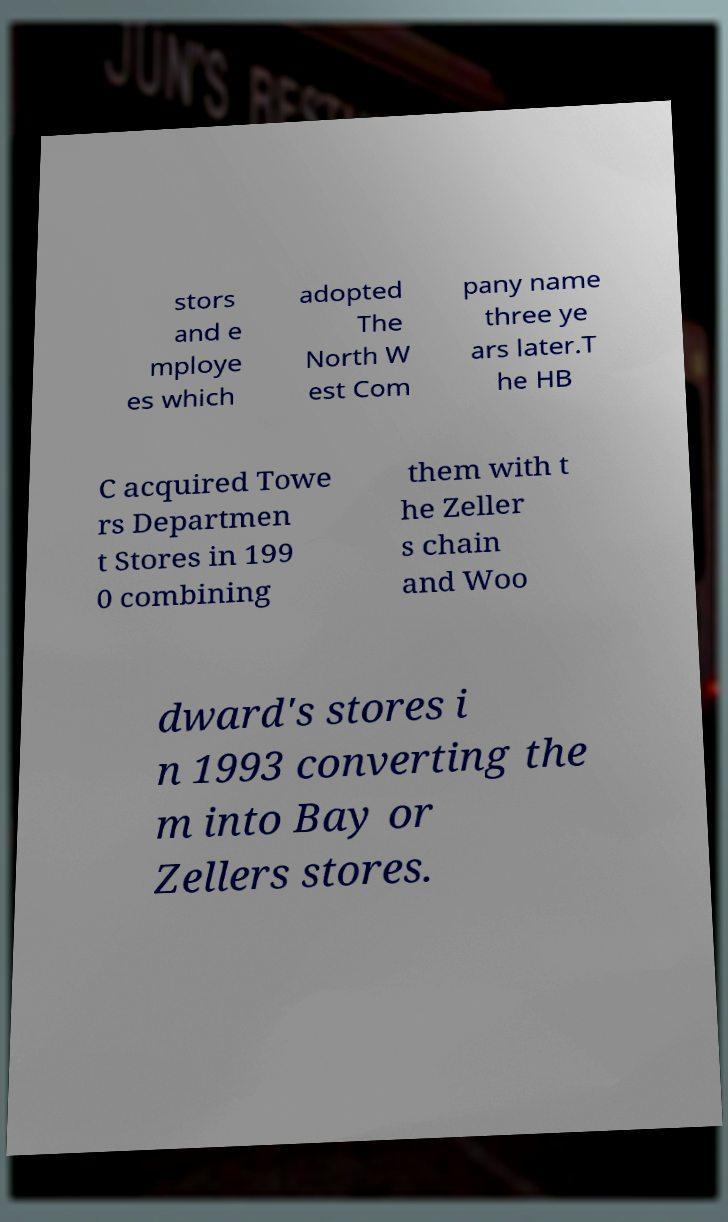Can you accurately transcribe the text from the provided image for me? stors and e mploye es which adopted The North W est Com pany name three ye ars later.T he HB C acquired Towe rs Departmen t Stores in 199 0 combining them with t he Zeller s chain and Woo dward's stores i n 1993 converting the m into Bay or Zellers stores. 